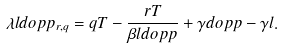Convert formula to latex. <formula><loc_0><loc_0><loc_500><loc_500>\lambda l d o p p _ { r , q } = q T - \frac { r T } { \beta l d o p p } + \gamma d o p p - \gamma l .</formula> 